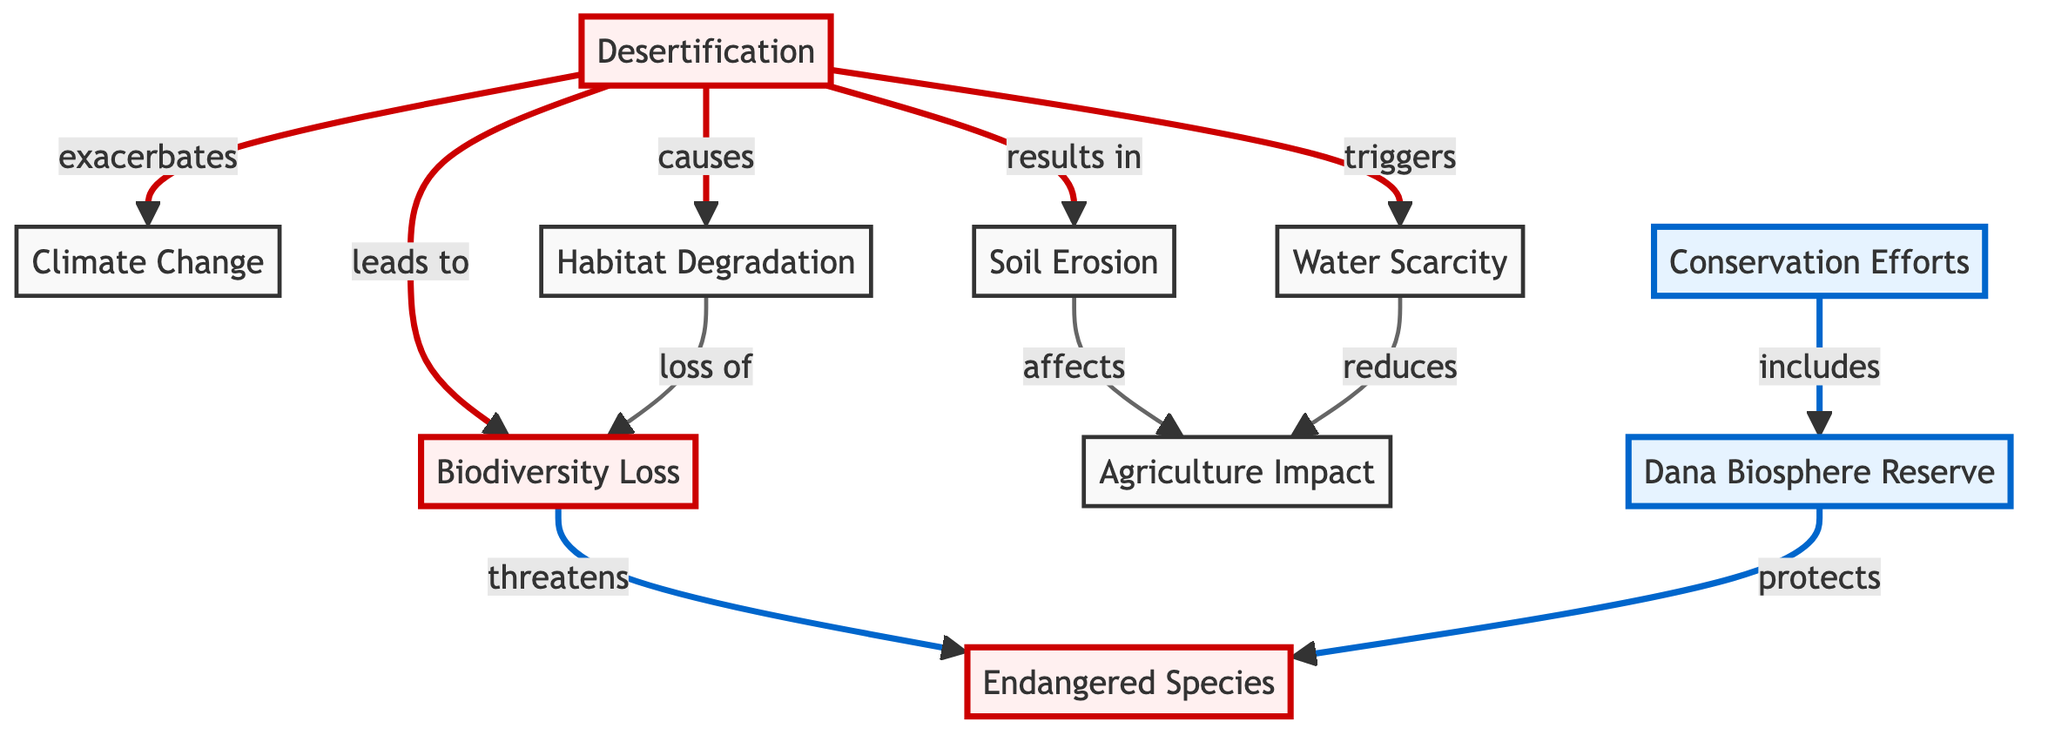What is the primary cause labeled in the diagram? The primary cause labeled in the diagram is 'Desertification,' which is prominently displayed at the starting point of the flowchart.
Answer: Desertification How many main nodes illustrate the impacts on biodiversity? The diagram identifies four main nodes that illustrate impacts related to biodiversity loss: Biodiversity Loss, Endangered Species, Habitat Degradation, and the role of Conservation Efforts.
Answer: Four What connection does desertification have with climate change? The diagram indicates that desertification 'exacerbates' climate change, showing a direct link between the two nodes.
Answer: Exacerbates What does 'Soil Erosion' affect according to the diagram? According to the diagram, 'Soil Erosion' affects 'Agriculture Impact,' as indicated by the directional arrow pointing to that node.
Answer: Agriculture Impact Which node protects endangered species? The 'Dana Biosphere Reserve' node is labeled in the diagram as the entity that protects endangered species, as shown by the flow from it to 'Endangered Species.'
Answer: Dana Biosphere Reserve How does water scarcity relate to agriculture? Water scarcity 'reduces' agriculture, as shown by the arrow from the 'Water Scarcity' node pointing to the 'Agriculture Impact' node in the diagram.
Answer: Reduces What is the final benefit included in the Conservation Efforts node? The diagram shows that Conservation Efforts 'includes' Dana Biosphere Reserve, highlighting its significance in conservation initiatives.
Answer: Includes How many distinct impacts of desertification are outlined in the diagram? The diagram outlines five distinct impacts of desertification: Biodiversity Loss, Climate Change, Habitat Degradation, Soil Erosion, and Water Scarcity.
Answer: Five Which node directly leads to biodiversity loss? The node 'Desertification' directly leads to 'Biodiversity Loss,' indicating a direct cause-and-effect relationship.
Answer: Desertification 